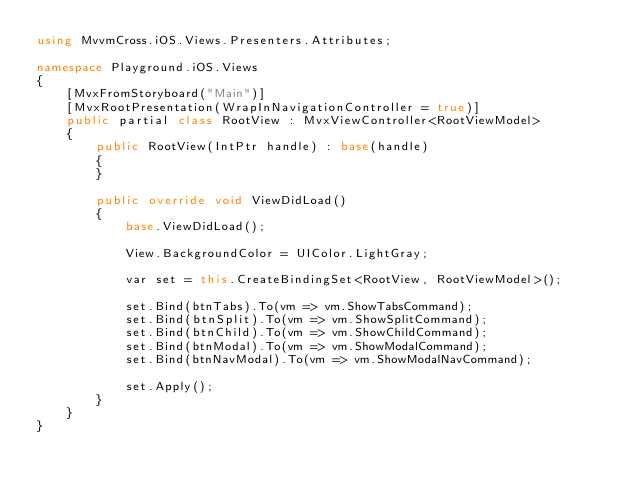Convert code to text. <code><loc_0><loc_0><loc_500><loc_500><_C#_>using MvvmCross.iOS.Views.Presenters.Attributes;

namespace Playground.iOS.Views
{
    [MvxFromStoryboard("Main")]
    [MvxRootPresentation(WrapInNavigationController = true)]
    public partial class RootView : MvxViewController<RootViewModel>
    {
        public RootView(IntPtr handle) : base(handle)
        {
        }

        public override void ViewDidLoad()
        {
            base.ViewDidLoad();

            View.BackgroundColor = UIColor.LightGray;

            var set = this.CreateBindingSet<RootView, RootViewModel>();

            set.Bind(btnTabs).To(vm => vm.ShowTabsCommand);
            set.Bind(btnSplit).To(vm => vm.ShowSplitCommand);
            set.Bind(btnChild).To(vm => vm.ShowChildCommand);
            set.Bind(btnModal).To(vm => vm.ShowModalCommand);
            set.Bind(btnNavModal).To(vm => vm.ShowModalNavCommand);

            set.Apply();
        }
    }
}</code> 